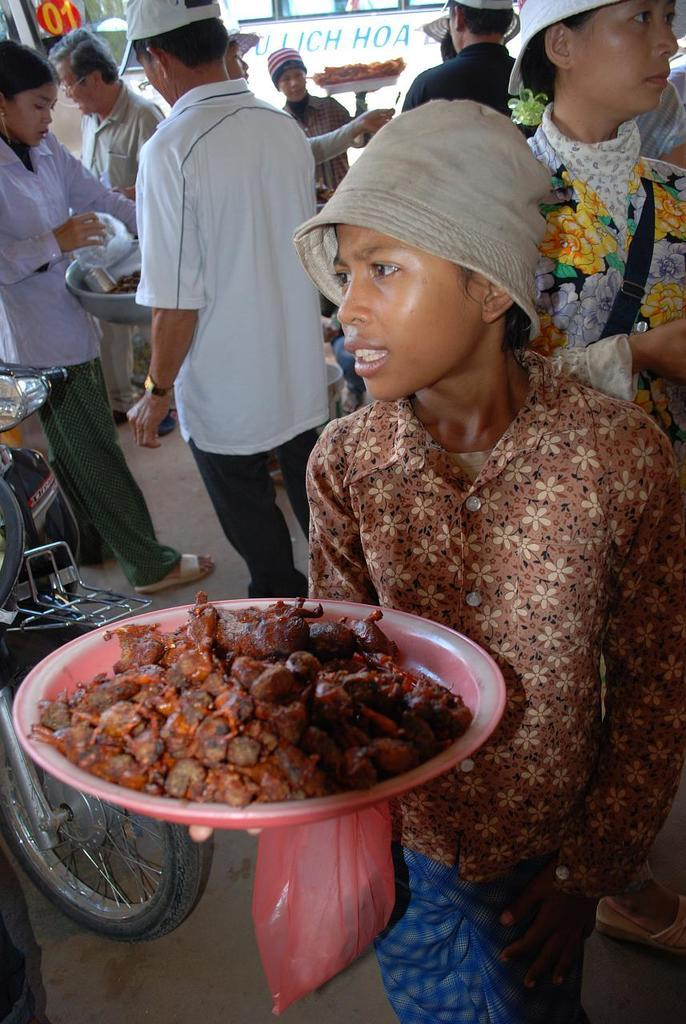How many people are in the image? There are many persons in the image. What is the boy in the front of the image holding? The boy is holding a plate in the front of the image. What is on the plate that the boy is holding? There is food on the plate. What can be seen to the left of the image? There is a bike to the left of the image. What part of the setting is visible at the bottom of the image? The floor is visible at the bottom of the image. Where is the nest located in the image? There is no nest present in the image. Can you see a tiger in the image? There is no tiger present in the image. 